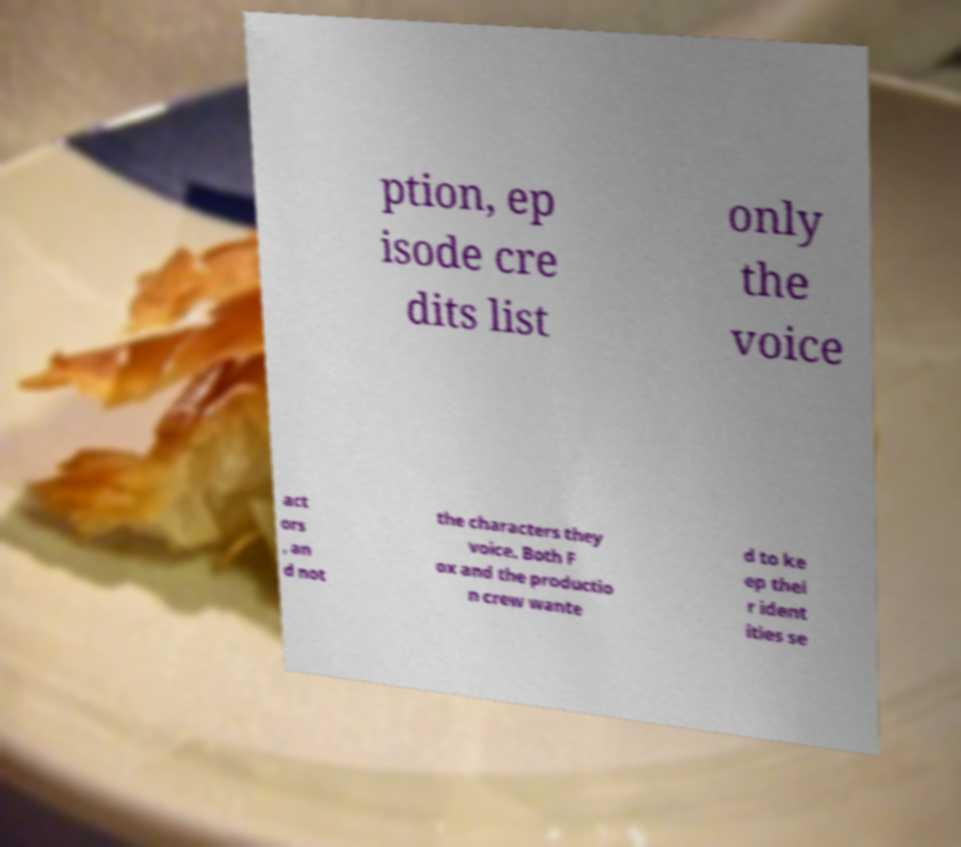Please identify and transcribe the text found in this image. ption, ep isode cre dits list only the voice act ors , an d not the characters they voice. Both F ox and the productio n crew wante d to ke ep thei r ident ities se 